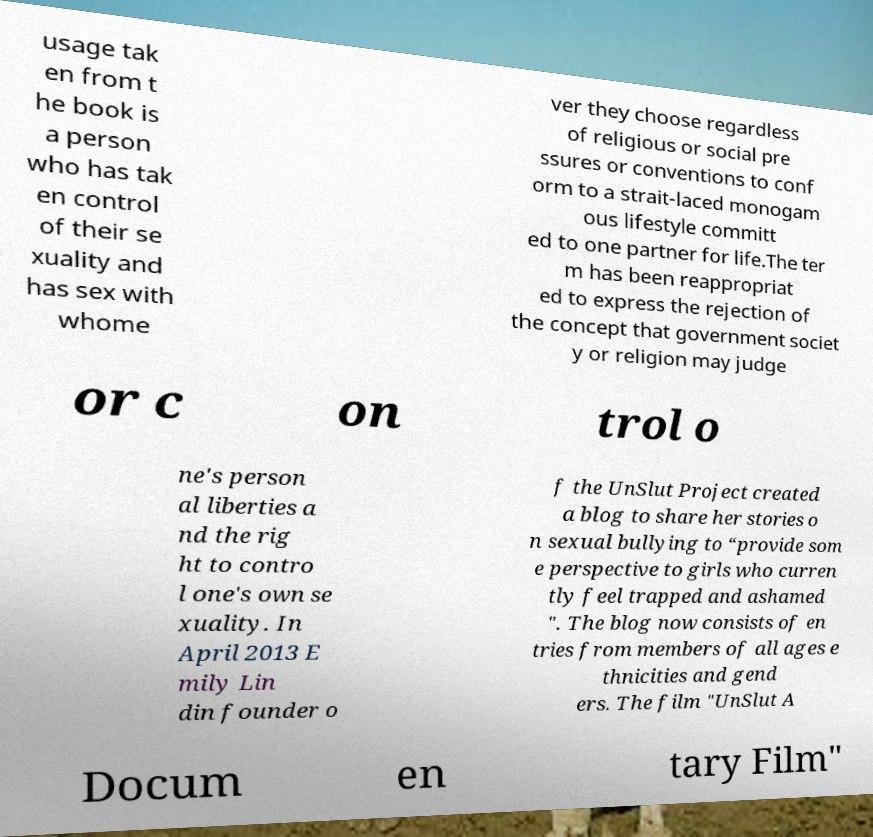Can you read and provide the text displayed in the image?This photo seems to have some interesting text. Can you extract and type it out for me? usage tak en from t he book is a person who has tak en control of their se xuality and has sex with whome ver they choose regardless of religious or social pre ssures or conventions to conf orm to a strait-laced monogam ous lifestyle committ ed to one partner for life.The ter m has been reappropriat ed to express the rejection of the concept that government societ y or religion may judge or c on trol o ne's person al liberties a nd the rig ht to contro l one's own se xuality. In April 2013 E mily Lin din founder o f the UnSlut Project created a blog to share her stories o n sexual bullying to “provide som e perspective to girls who curren tly feel trapped and ashamed ". The blog now consists of en tries from members of all ages e thnicities and gend ers. The film "UnSlut A Docum en tary Film" 